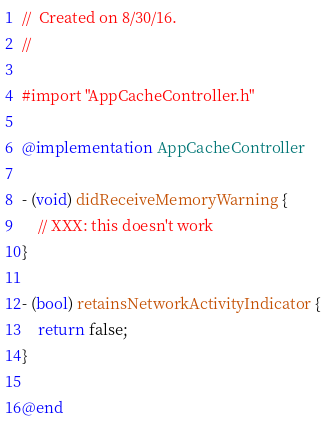Convert code to text. <code><loc_0><loc_0><loc_500><loc_500><_ObjectiveC_>//  Created on 8/30/16.
//

#import "AppCacheController.h"

@implementation AppCacheController

- (void) didReceiveMemoryWarning {
    // XXX: this doesn't work
}

- (bool) retainsNetworkActivityIndicator {
    return false;
}

@end</code> 